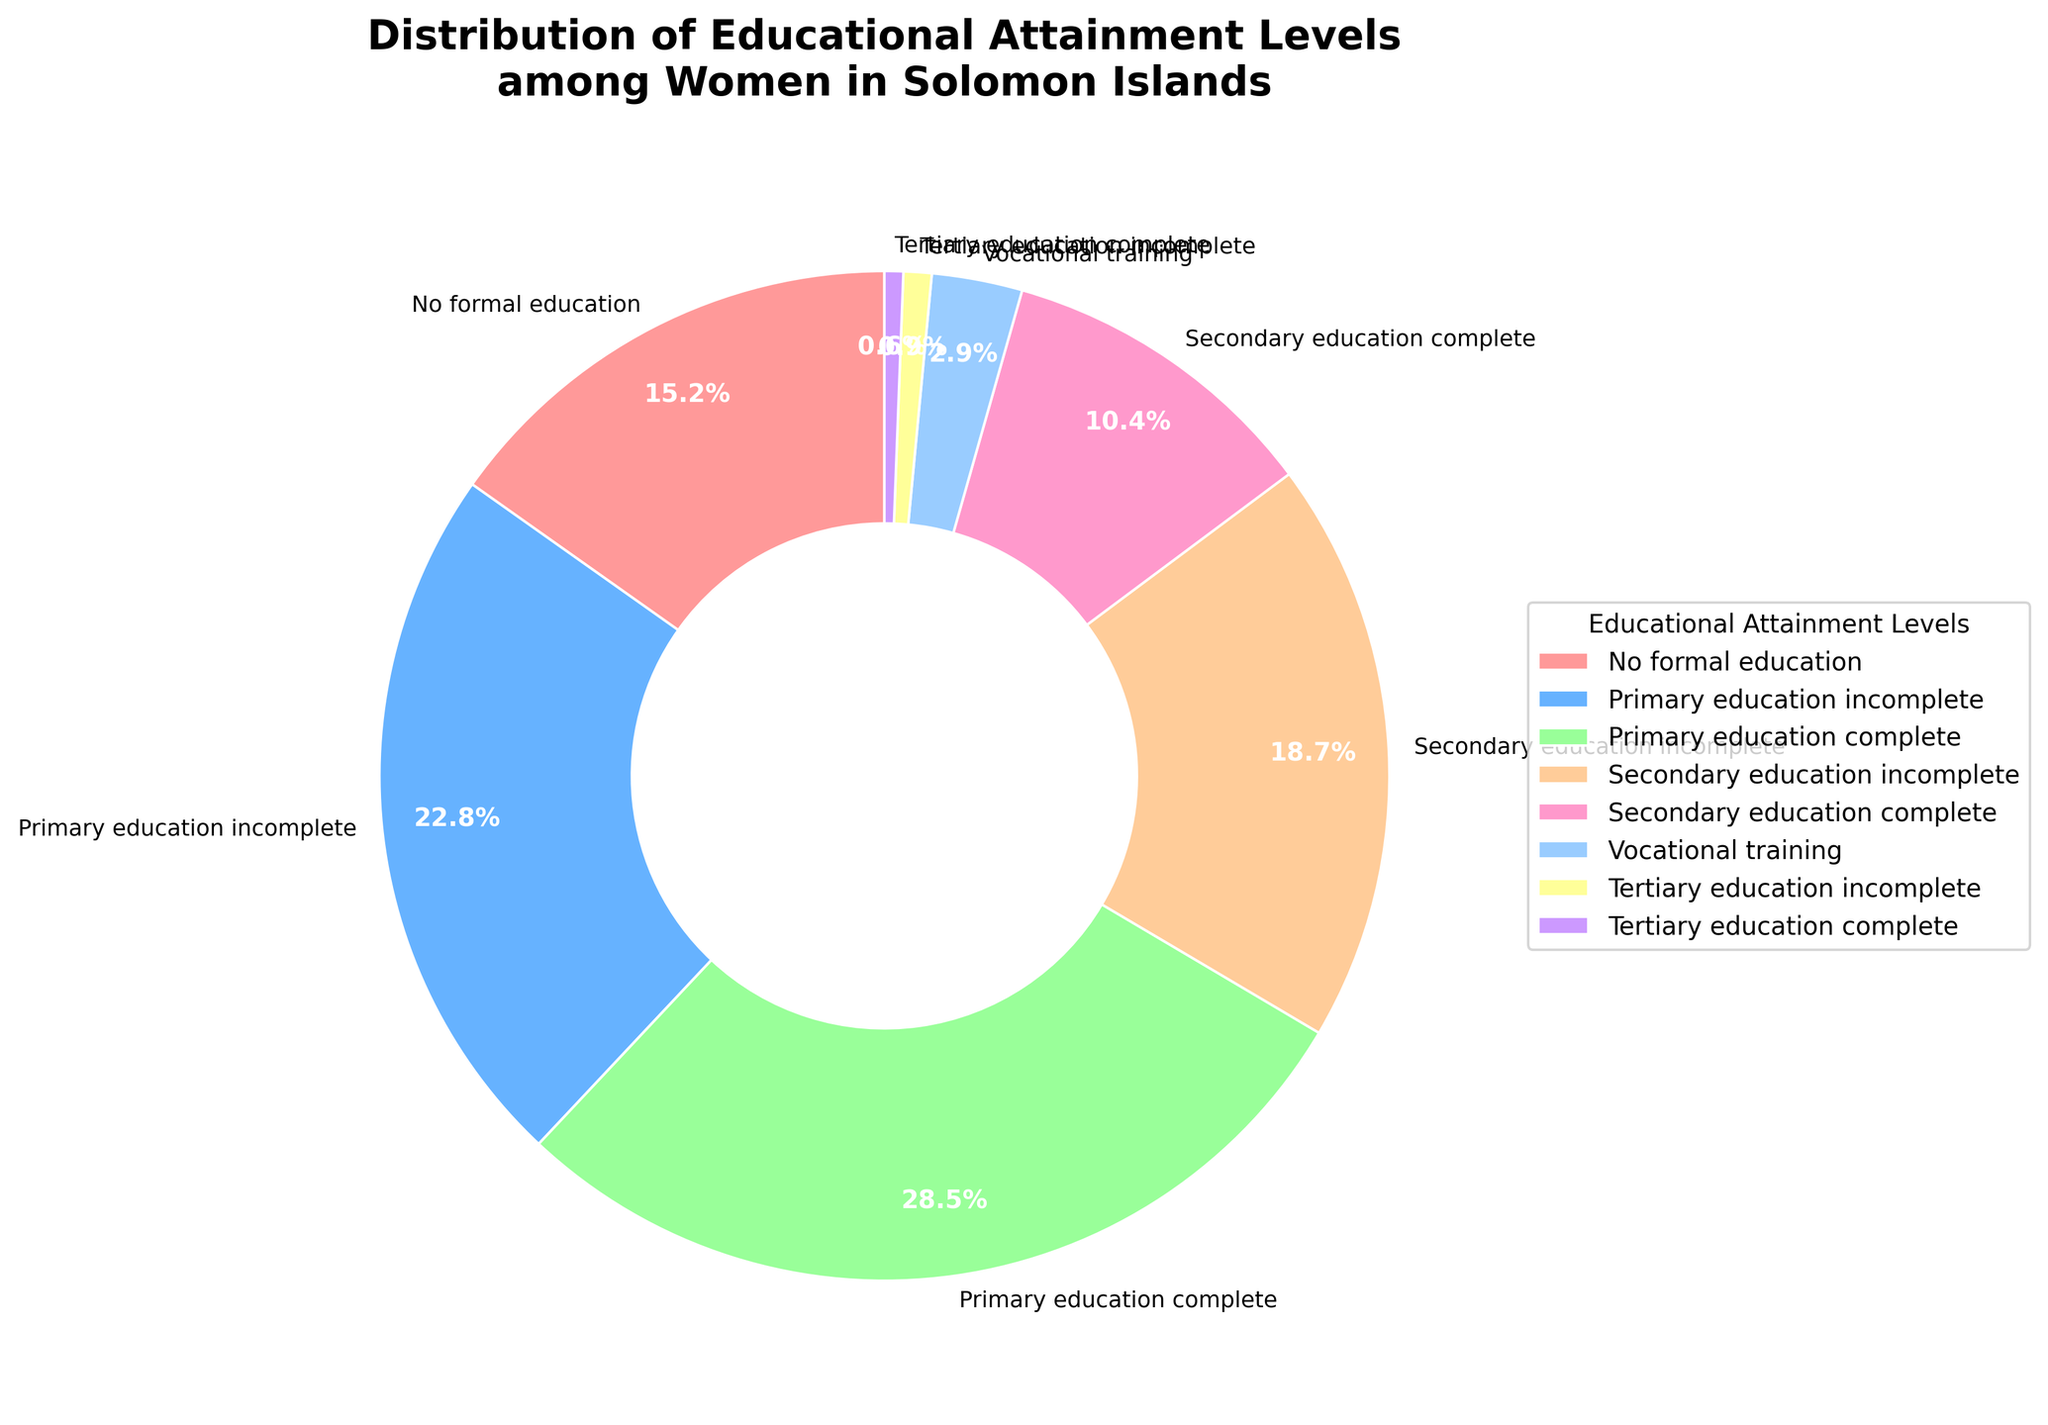Which educational attainment level has the highest percentage among women in the Solomon Islands? The largest segment of the pie chart is identified by the label "Primary education complete," and its percentage is 28.5%.
Answer: Primary education complete What is the combined percentage of women with no formal education and those who only completed primary education? Adding the percentages for "No formal education" (15.2%) and "Primary education complete" (28.5%) gives 15.2 + 28.5 = 43.7%.
Answer: 43.7% Which educational levels together represent more than 50% of the distribution? Summing the percentages from the highest downwards: "Primary education complete" (28.5%) + "Primary education incomplete" (22.8%) = 51.3%, which is already greater than 50%.
Answer: Primary education complete and Primary education incomplete How does the percentage of women who completed secondary education compare to those with no formal education? The percentage of women who completed secondary education (10.4%) is less than the percentage of women with no formal education (15.2%).
Answer: Less Which educational attainment level segment is represented in blue on the pie chart? The segment represented in blue corresponds to the percentage listed for "Primary education incomplete" (22.8%).
Answer: Primary education incomplete What is the total percentage of women who have at least started secondary education? Adding the percentages for "Secondary education incomplete" (18.7%), "Secondary education complete" (10.4%), "Vocational training" (2.9%), "Tertiary education incomplete" (0.9%), and "Tertiary education complete" (0.6%) gives 18.7 + 10.4 + 2.9 + 0.9 + 0.6 = 33.5%.
Answer: 33.5% What is the difference between the percentage of women who have completed tertiary education and those who have vocational training? The difference between "Vocational training" (2.9%) and "Tertiary education complete" (0.6%) is 2.9 - 0.6 = 2.3%.
Answer: 2.3% How many educational attainment levels are represented in the pie chart? Counting the number of wedge labels on the pie chart gives a total of 8 different educational attainment levels.
Answer: 8 What proportion of women have not completed any formal education or primary education? Adding the percentages for "No formal education" (15.2%) and "Primary education incomplete" (22.8%) gives 15.2 + 22.8 = 38%.
Answer: 38% Compare the percentage of women with vocational training to those with only secondary education complete. The percentage of women with vocational training (2.9%) is less than the percentage of women with secondary education complete (10.4%).
Answer: Less 